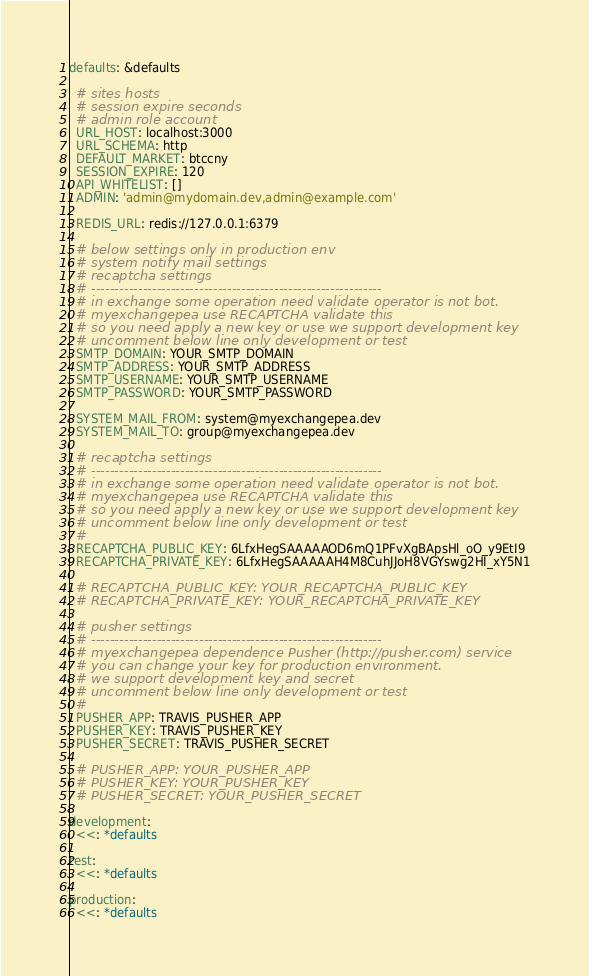Convert code to text. <code><loc_0><loc_0><loc_500><loc_500><_YAML_>defaults: &defaults

  # sites hosts
  # session expire seconds
  # admin role account
  URL_HOST: localhost:3000
  URL_SCHEMA: http
  DEFAULT_MARKET: btccny
  SESSION_EXPIRE: 120
  API_WHITELIST: []
  ADMIN: 'admin@mydomain.dev,admin@example.com'

  REDIS_URL: redis://127.0.0.1:6379

  # below settings only in production env
  # system notify mail settings
  # recaptcha settings
  # --------------------------------------------------------------
  # in exchange some operation need validate operator is not bot.
  # myexchangepea use RECAPTCHA validate this
  # so you need apply a new key or use we support development key
  # uncomment below line only development or test
  SMTP_DOMAIN: YOUR_SMTP_DOMAIN
  SMTP_ADDRESS: YOUR_SMTP_ADDRESS
  SMTP_USERNAME: YOUR_SMTP_USERNAME
  SMTP_PASSWORD: YOUR_SMTP_PASSWORD

  SYSTEM_MAIL_FROM: system@myexchangepea.dev
  SYSTEM_MAIL_TO: group@myexchangepea.dev

  # recaptcha settings
  # --------------------------------------------------------------
  # in exchange some operation need validate operator is not bot.
  # myexchangepea use RECAPTCHA validate this
  # so you need apply a new key or use we support development key
  # uncomment below line only development or test
  #
  RECAPTCHA_PUBLIC_KEY: 6LfxHegSAAAAAOD6mQ1PFvXgBApsHl_oO_y9EtI9
  RECAPTCHA_PRIVATE_KEY: 6LfxHegSAAAAAH4M8CuhJJoH8VGYswg2HI_xY5N1

  # RECAPTCHA_PUBLIC_KEY: YOUR_RECAPTCHA_PUBLIC_KEY
  # RECAPTCHA_PRIVATE_KEY: YOUR_RECAPTCHA_PRIVATE_KEY

  # pusher settings
  # --------------------------------------------------------------
  # myexchangepea dependence Pusher (http://pusher.com) service
  # you can change your key for production environment.
  # we support development key and secret
  # uncomment below line only development or test
  #
  PUSHER_APP: TRAVIS_PUSHER_APP
  PUSHER_KEY: TRAVIS_PUSHER_KEY
  PUSHER_SECRET: TRAVIS_PUSHER_SECRET

  # PUSHER_APP: YOUR_PUSHER_APP
  # PUSHER_KEY: YOUR_PUSHER_KEY
  # PUSHER_SECRET: YOUR_PUSHER_SECRET

development:
  <<: *defaults

test:
  <<: *defaults

production:
  <<: *defaults
</code> 